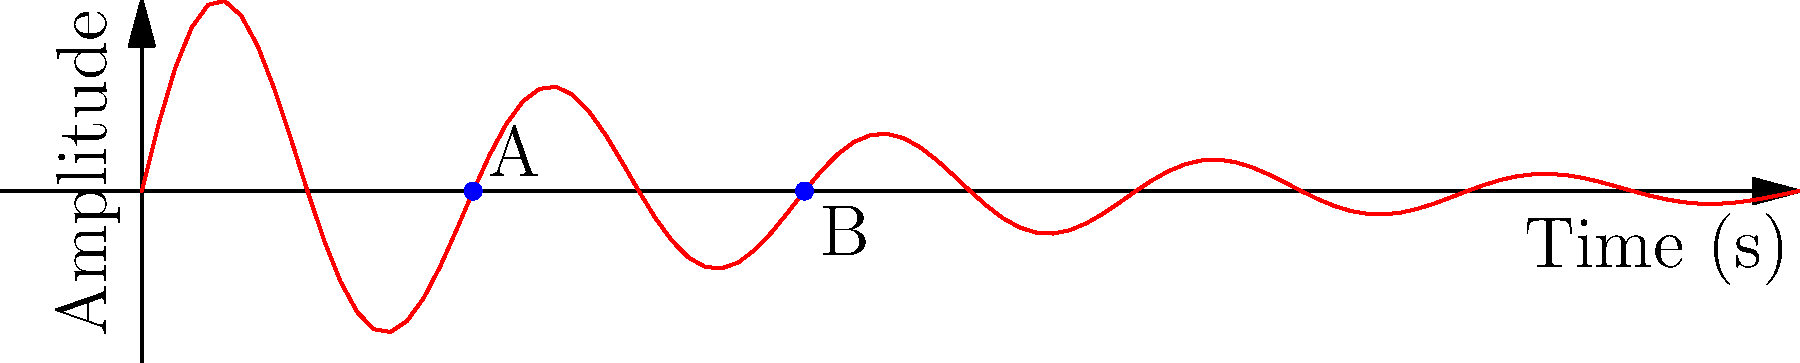Based on the seismic wave diagram above, which represents ground motion during an earthquake, what can be inferred about the relative intensity of the earthquake at points A and B? To interpret the seismic wave diagram and compare the earthquake intensity at points A and B, we need to follow these steps:

1. Understand what the diagram represents:
   - The x-axis represents time in seconds.
   - The y-axis represents the amplitude of ground motion.
   - The red curve shows the seismic wave pattern.

2. Analyze the wave characteristics:
   - The wave amplitude decreases over time, which is typical for seismic waves due to energy dissipation.
   - The frequency of the wave remains relatively constant.

3. Locate points A and B:
   - Point A is at an earlier time (around 3 seconds) with a higher amplitude.
   - Point B is at a later time (around 6 seconds) with a lower amplitude.

4. Compare the amplitudes:
   - The amplitude at point A is noticeably higher than at point B.
   - In seismology, higher amplitude generally correlates with greater ground motion and higher intensity.

5. Consider the time factor:
   - Point A occurs earlier in the seismic event than point B.
   - Typically, the most intense shaking occurs earlier in an earthquake, closer to the initial rupture.

6. Draw a conclusion:
   - Based on the higher amplitude and earlier occurrence, the earthquake intensity at point A is greater than at point B.

Therefore, the seismic wave diagram indicates that the relative intensity of the earthquake is higher at point A compared to point B.
Answer: Higher intensity at A than B 